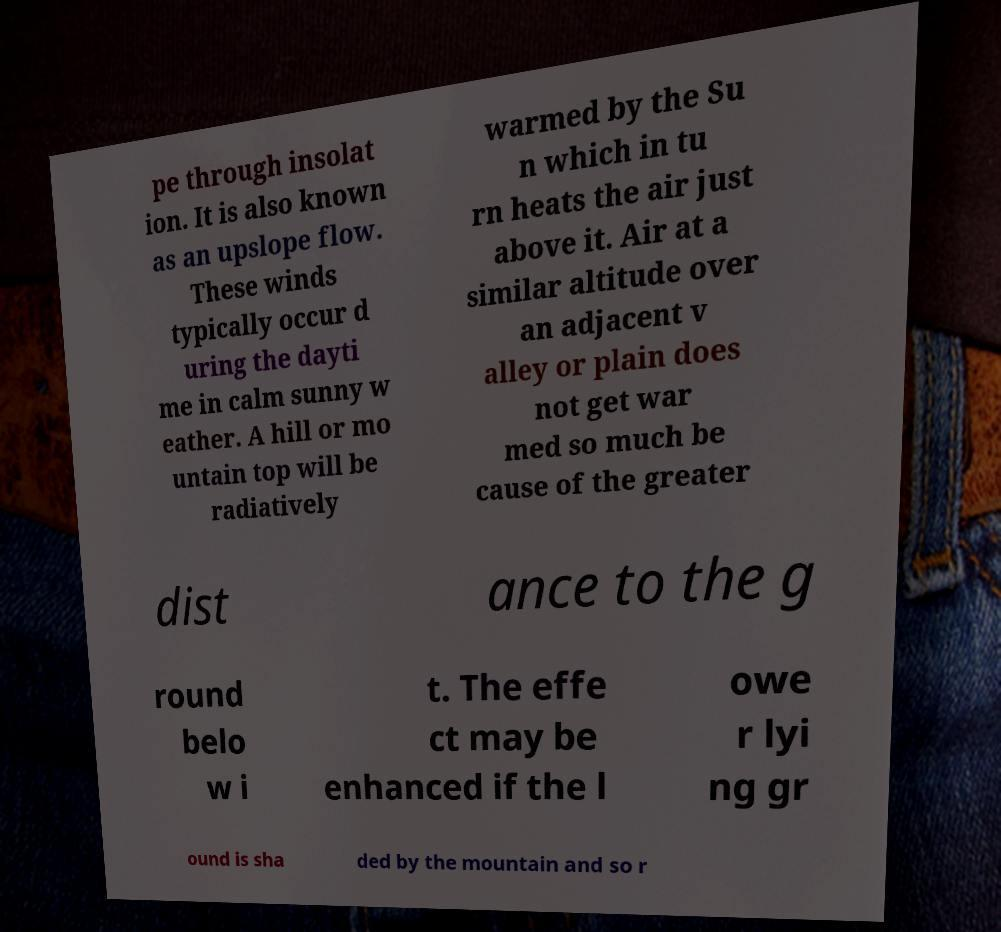Please identify and transcribe the text found in this image. pe through insolat ion. It is also known as an upslope flow. These winds typically occur d uring the dayti me in calm sunny w eather. A hill or mo untain top will be radiatively warmed by the Su n which in tu rn heats the air just above it. Air at a similar altitude over an adjacent v alley or plain does not get war med so much be cause of the greater dist ance to the g round belo w i t. The effe ct may be enhanced if the l owe r lyi ng gr ound is sha ded by the mountain and so r 